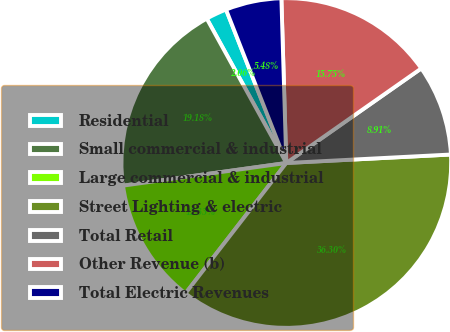<chart> <loc_0><loc_0><loc_500><loc_500><pie_chart><fcel>Residential<fcel>Small commercial & industrial<fcel>Large commercial & industrial<fcel>Street Lighting & electric<fcel>Total Retail<fcel>Other Revenue (b)<fcel>Total Electric Revenues<nl><fcel>2.06%<fcel>19.18%<fcel>12.33%<fcel>36.3%<fcel>8.91%<fcel>15.75%<fcel>5.48%<nl></chart> 